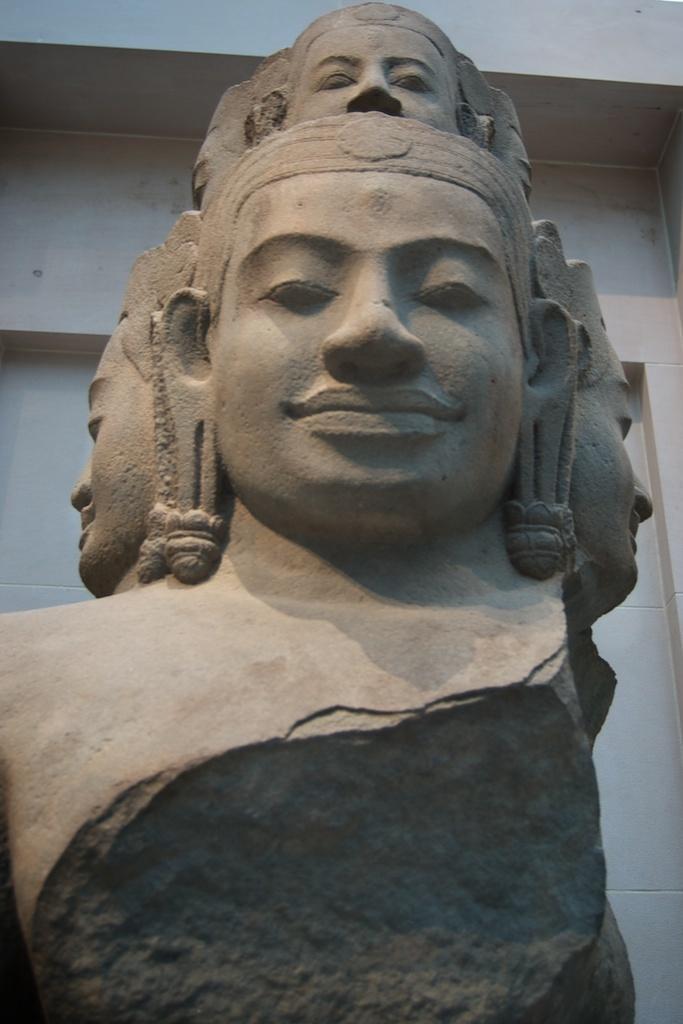Please provide a concise description of this image. This image consists of a sculpture made up of rock. In the background, there is a wall. 